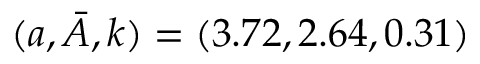Convert formula to latex. <formula><loc_0><loc_0><loc_500><loc_500>( a , \ B a r { A } , k ) = ( 3 . 7 2 , 2 . 6 4 , 0 . 3 1 )</formula> 